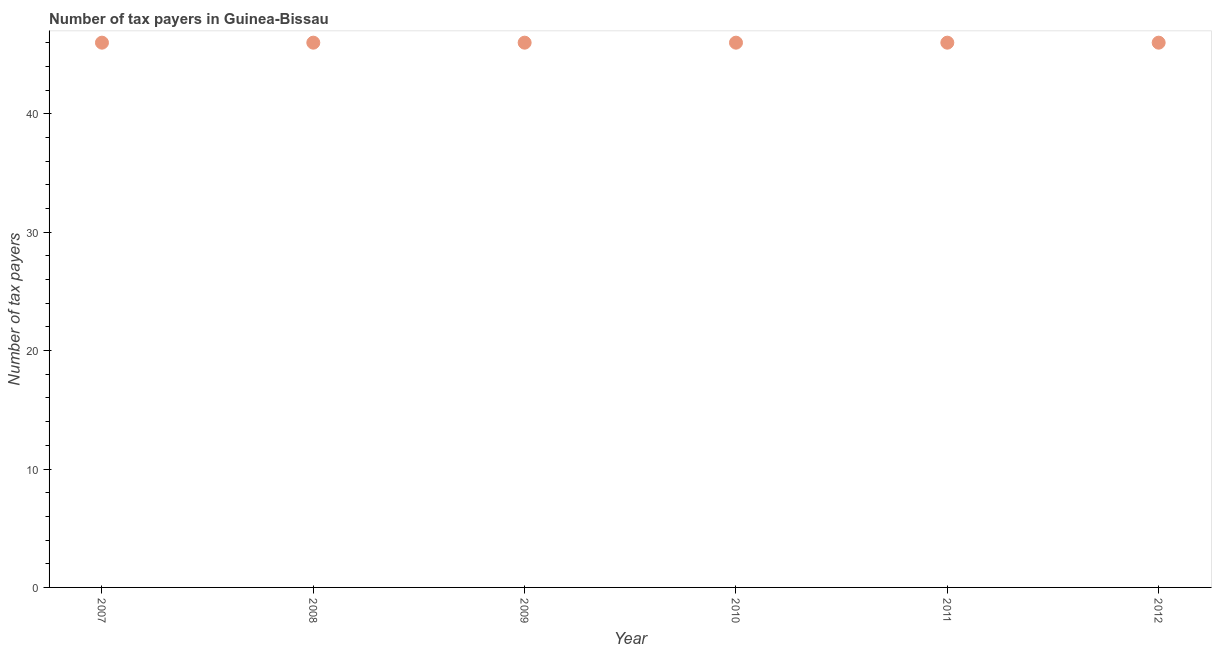What is the number of tax payers in 2008?
Your answer should be compact. 46. Across all years, what is the maximum number of tax payers?
Your answer should be very brief. 46. Across all years, what is the minimum number of tax payers?
Your answer should be compact. 46. In which year was the number of tax payers minimum?
Offer a very short reply. 2007. What is the sum of the number of tax payers?
Your response must be concise. 276. What is the median number of tax payers?
Your answer should be very brief. 46. Is the number of tax payers in 2009 less than that in 2012?
Your answer should be very brief. No. What is the difference between the highest and the lowest number of tax payers?
Ensure brevity in your answer.  0. How many dotlines are there?
Provide a short and direct response. 1. How many years are there in the graph?
Your answer should be very brief. 6. What is the difference between two consecutive major ticks on the Y-axis?
Offer a very short reply. 10. What is the title of the graph?
Offer a terse response. Number of tax payers in Guinea-Bissau. What is the label or title of the X-axis?
Provide a succinct answer. Year. What is the label or title of the Y-axis?
Give a very brief answer. Number of tax payers. What is the Number of tax payers in 2008?
Offer a terse response. 46. What is the Number of tax payers in 2012?
Provide a short and direct response. 46. What is the difference between the Number of tax payers in 2007 and 2009?
Your answer should be compact. 0. What is the difference between the Number of tax payers in 2007 and 2011?
Offer a terse response. 0. What is the difference between the Number of tax payers in 2008 and 2009?
Provide a short and direct response. 0. What is the difference between the Number of tax payers in 2008 and 2010?
Make the answer very short. 0. What is the difference between the Number of tax payers in 2009 and 2010?
Ensure brevity in your answer.  0. What is the difference between the Number of tax payers in 2009 and 2011?
Your answer should be very brief. 0. What is the difference between the Number of tax payers in 2010 and 2011?
Offer a very short reply. 0. What is the ratio of the Number of tax payers in 2007 to that in 2008?
Your response must be concise. 1. What is the ratio of the Number of tax payers in 2007 to that in 2009?
Ensure brevity in your answer.  1. What is the ratio of the Number of tax payers in 2007 to that in 2010?
Keep it short and to the point. 1. What is the ratio of the Number of tax payers in 2008 to that in 2009?
Your answer should be very brief. 1. What is the ratio of the Number of tax payers in 2008 to that in 2011?
Give a very brief answer. 1. What is the ratio of the Number of tax payers in 2009 to that in 2010?
Your answer should be compact. 1. What is the ratio of the Number of tax payers in 2009 to that in 2012?
Your response must be concise. 1. What is the ratio of the Number of tax payers in 2010 to that in 2012?
Keep it short and to the point. 1. What is the ratio of the Number of tax payers in 2011 to that in 2012?
Keep it short and to the point. 1. 